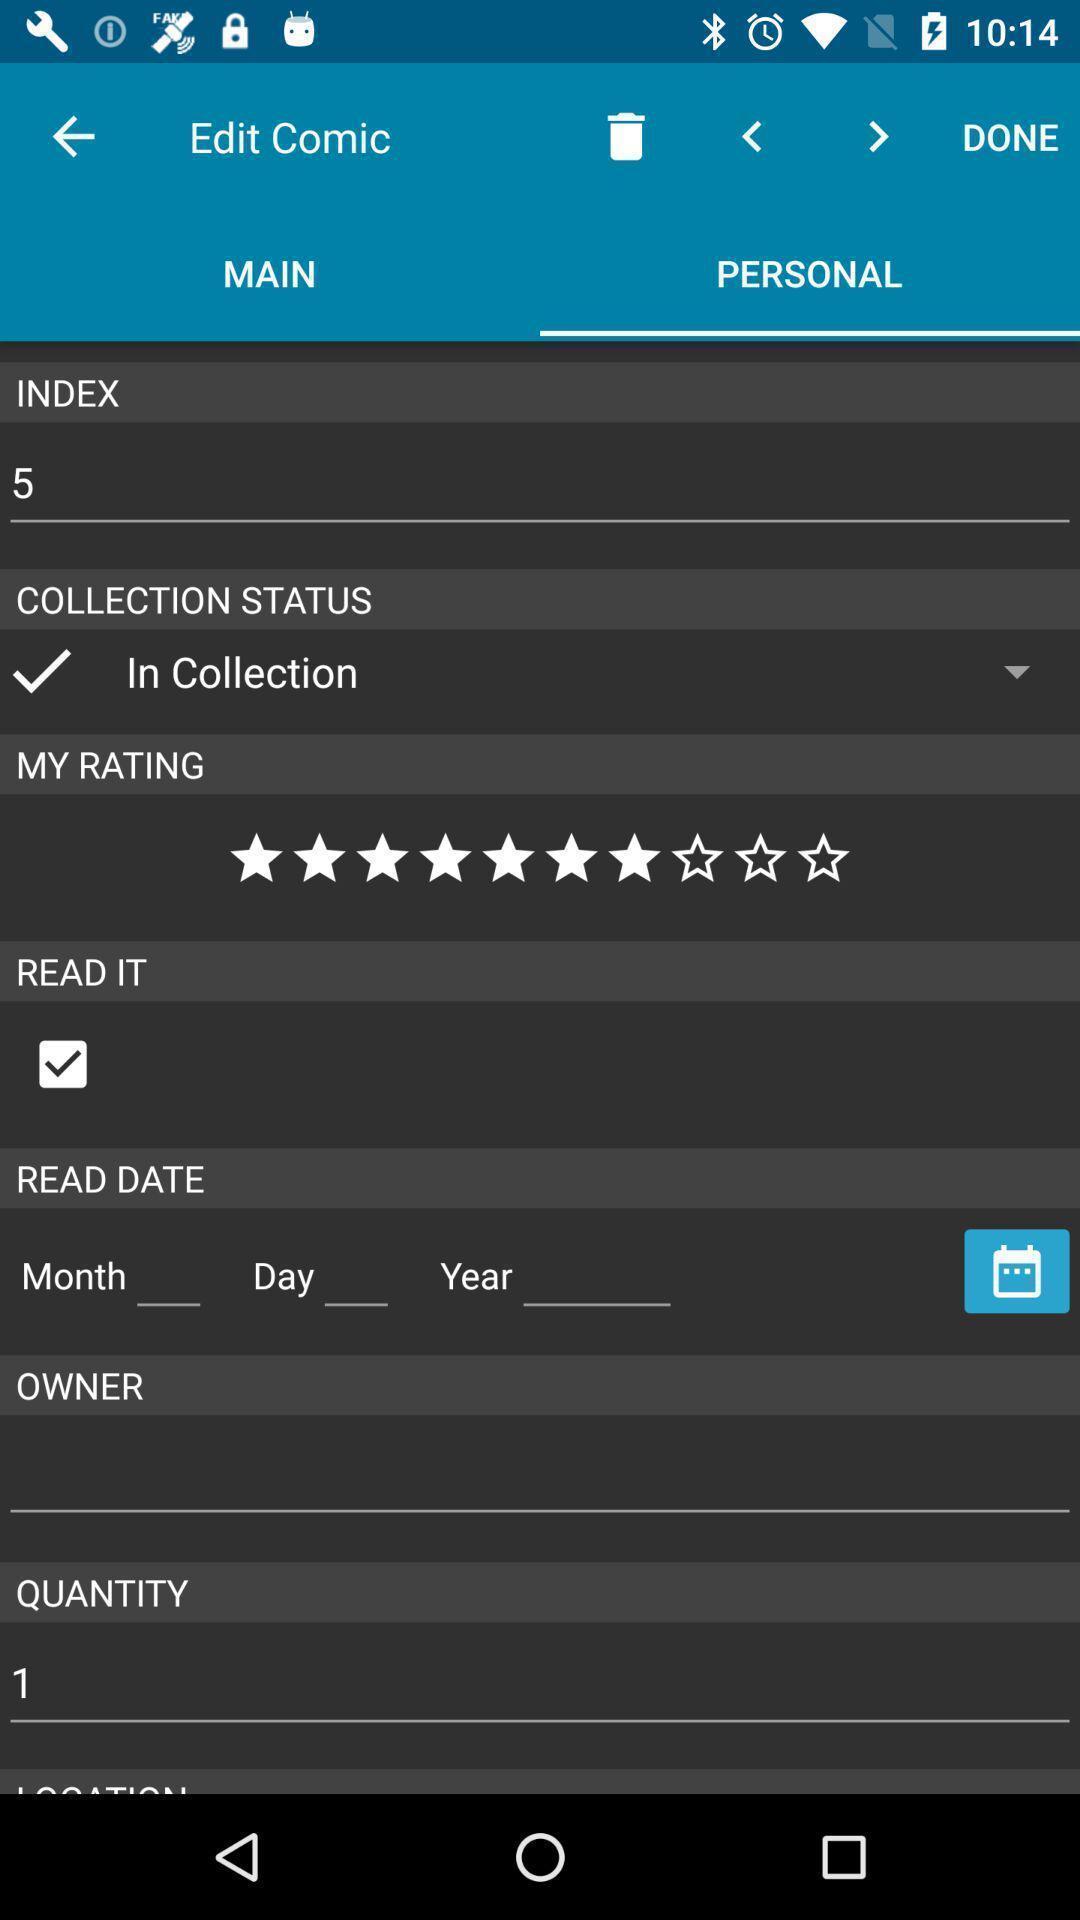Explain the elements present in this screenshot. Page showing the options in personal tab. 